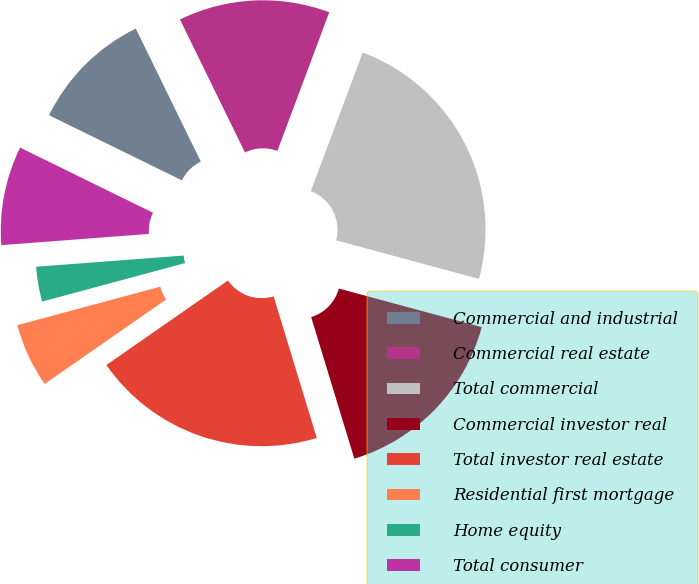<chart> <loc_0><loc_0><loc_500><loc_500><pie_chart><fcel>Commercial and industrial<fcel>Commercial real estate<fcel>Total commercial<fcel>Commercial investor real<fcel>Total investor real estate<fcel>Residential first mortgage<fcel>Home equity<fcel>Total consumer<nl><fcel>10.51%<fcel>12.93%<fcel>23.5%<fcel>16.09%<fcel>20.04%<fcel>5.48%<fcel>2.98%<fcel>8.46%<nl></chart> 